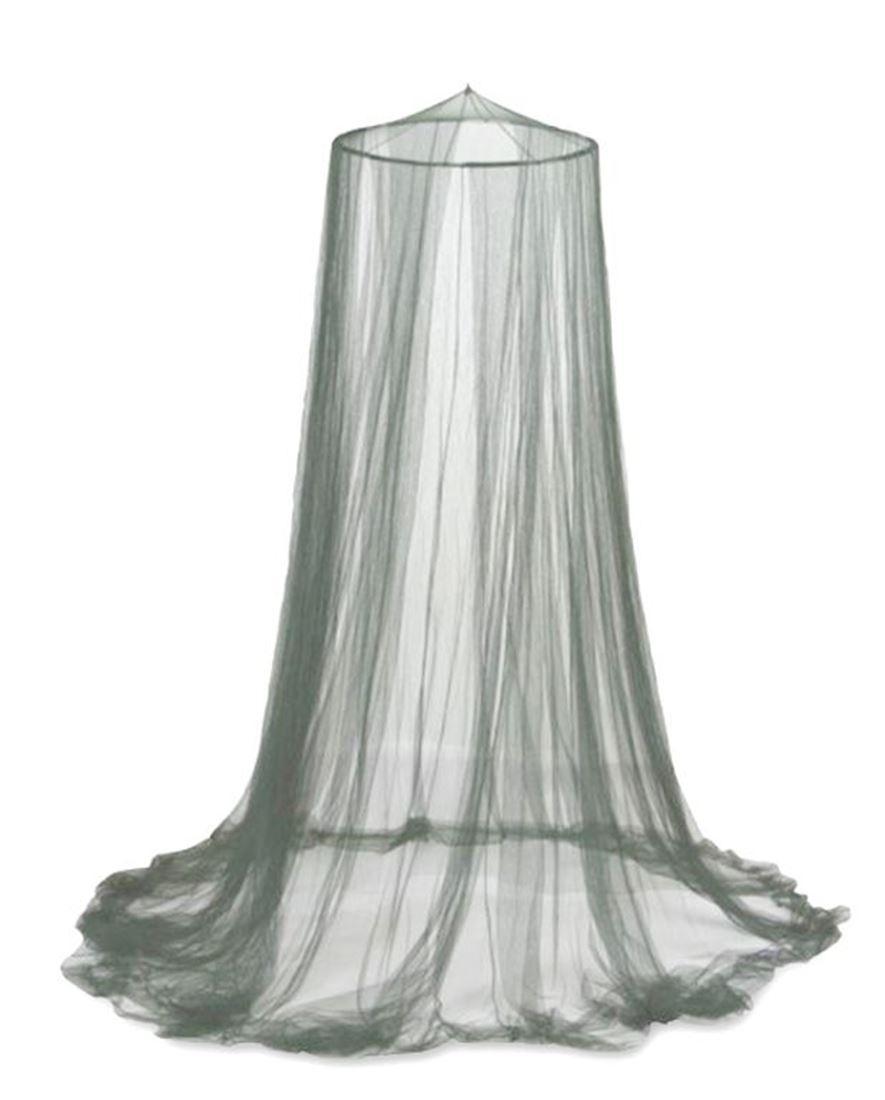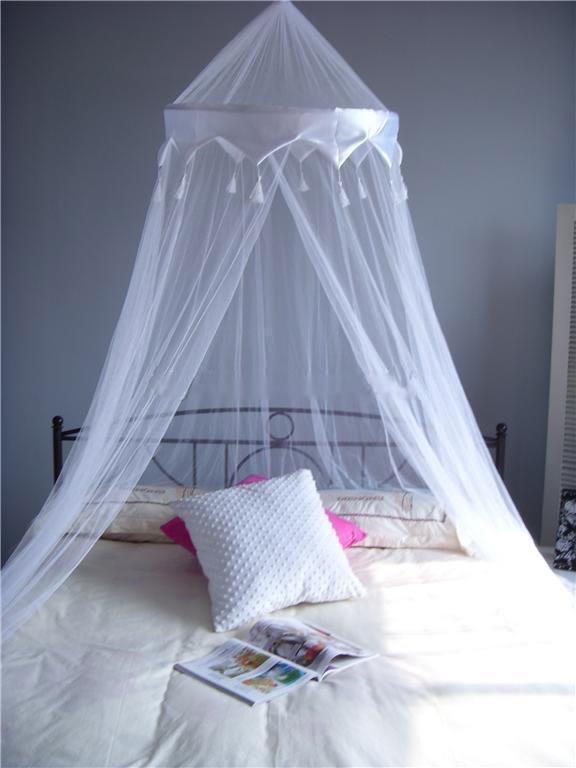The first image is the image on the left, the second image is the image on the right. Evaluate the accuracy of this statement regarding the images: "Each image shows a gauzy white canopy that drapes from a cone shape suspended from the ceiling, but only the left image shows a canopy over a bed.". Is it true? Answer yes or no. No. The first image is the image on the left, the second image is the image on the right. For the images shown, is this caption "There is at least one window behind the canopy in one of the images" true? Answer yes or no. No. 